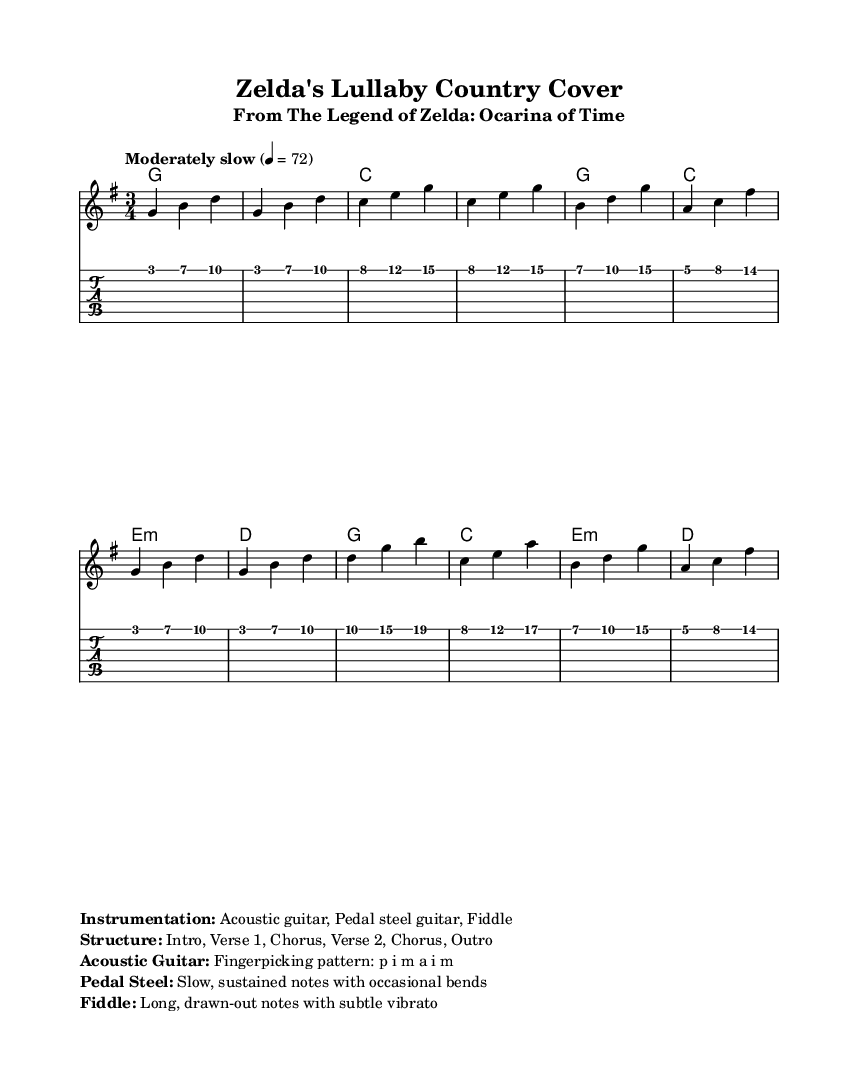What is the key signature of this music? The key signature is G major, which has one sharp (F#). You can identify the key signature at the beginning of the staff, where it indicates the presence of one sharp.
Answer: G major What is the time signature of this piece? The time signature is 3/4, which means there are three beats in each measure with a quarter note receiving one beat. This can be observed in the time signature notation at the beginning of the music.
Answer: 3/4 What is the tempo marking for this piece? The tempo marking is "Moderately slow" with a metronome marking of 72 beats per minute. This can be found in the tempo indication above the staff, specifying the speed of the piece.
Answer: Moderately slow How many sections are there in the structure of the song? The structure consists of five distinct sections: Intro, Verse 1, Chorus, Verse 2, and Outro. This breakdown of sections can be noted in the instrumentation markings provided at the end of the score.
Answer: Five What kind of instrumentation is used in this cover? The instrumentation includes Acoustic guitar, Pedal steel guitar, and Fiddle. This information is listed in the markup section below the staff and gives insight into the unique sound of the cover.
Answer: Acoustic guitar, Pedal steel guitar, Fiddle What is the fingerpicking pattern indicated for the acoustic guitar? The fingerpicking pattern for the acoustic guitar is p i m a i m, which stands for the thumb, index, middle, and ring fingers. This pattern is specified in the instrumentation details for how to play the guitar part.
Answer: p i m a i m Which technique is specified for the pedal steel guitar? The pedal steel guitar is indicated to use slow, sustained notes with occasional bends. This is articulated in the instrumentation section, showcasing a characteristic technique often used in country music.
Answer: Slow, sustained notes with occasional bends 